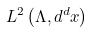<formula> <loc_0><loc_0><loc_500><loc_500>L ^ { 2 } \left ( \Lambda , d ^ { d } x \right )</formula> 